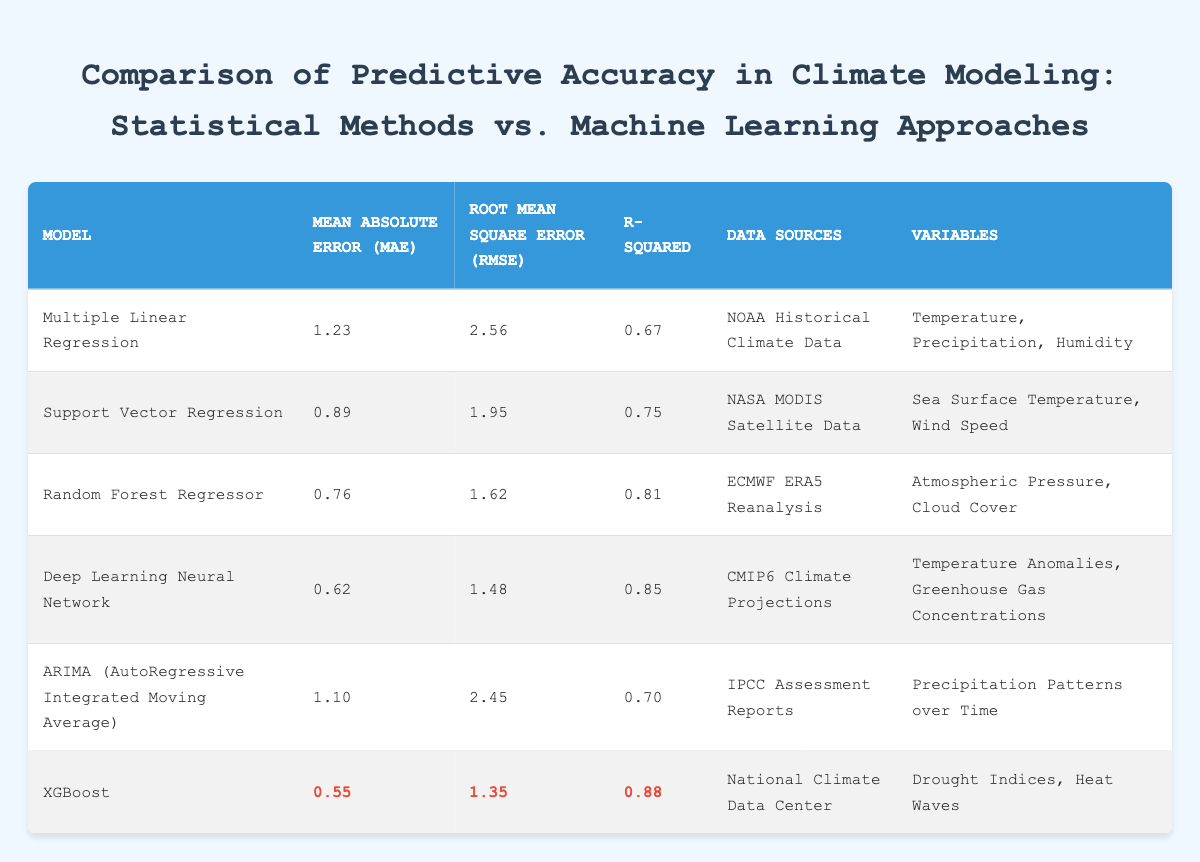What is the Mean Absolute Error (MAE) for the Random Forest Regressor? The table shows that the Mean Absolute Error (MAE) for the Random Forest Regressor is listed directly. By locating the corresponding row for Random Forest Regressor, we find the MAE value which is 0.76.
Answer: 0.76 Which model has the highest R-squared value? To determine the model with the highest R-squared value, we must compare the R-squared entries for each model listed in the table. The values are 0.67, 0.75, 0.81, 0.85, 0.70, and 0.88. The highest of these values is 0.88, which corresponds to the XGBoost model.
Answer: XGBoost What is the difference in Mean Absolute Error (MAE) between the Deep Learning Neural Network and the Multiple Linear Regression model? First, we identify the MAE values for both the Deep Learning Neural Network (0.62) and the Multiple Linear Regression (1.23). We then calculate the difference: 1.23 - 0.62 = 0.61.
Answer: 0.61 Is the Mean Absolute Error (MAE) for Support Vector Regression less than that of ARIMA? The MAE for Support Vector Regression is 0.89, and the MAE for ARIMA is 1.10. Comparing these values: 0.89 < 1.10 is true, thus supporting the statement.
Answer: Yes What is the average R-squared value of all the models listed in the table? We must find the R-squared values for all models: 0.67, 0.75, 0.81, 0.85, 0.70, and 0.88. Adding these values gives us 0.67 + 0.75 + 0.81 + 0.85 + 0.70 + 0.88 = 4.56. Since there are 6 models, we divide the total by 6: 4.56/6 = 0.76.
Answer: 0.76 Which model, based on the table, has the lowest Root Mean Square Error (RMSE)? The RMSE values for the models are: 2.56, 1.95, 1.62, 1.48, 2.45, and 1.35. To find the model with the lowest RMSE, we compare these values. The lowest is 1.35, which corresponds to the XGBoost model.
Answer: XGBoost How does the Mean Absolute Error (MAE) of XGBoost compare with that of the Deep Learning Neural Network? The table indicates that XGBoost has an MAE of 0.55 and the Deep Learning Neural Network has an MAE of 0.62. To compare: 0.55 < 0.62 indicates that XGBoost has a lower MAE than the Deep Learning Neural Network.
Answer: XGBoost has a lower MAE What is the total number of models that reported data from the NASA MODIS Satellite Data? Checking the table, we look for data sources that mention "NASA MODIS Satellite Data". Only the Support Vector Regression model lists this source, therefore the total number is 1.
Answer: 1 If you combine the R-squared values of Random Forest Regressor and XGBoost, what is the total? The R-squared for Random Forest Regressor is 0.81 and for XGBoost it is 0.88. Adding these together results in 0.81 + 0.88 = 1.69.
Answer: 1.69 Which statistical model had a higher Mean Absolute Error (MAE), Deep Learning Neural Network or Multiple Linear Regression? The MAE for Deep Learning Neural Network is 0.62, while for Multiple Linear Regression it is 1.23. Comparing the two values shows 1.23 > 0.62, meaning Multiple Linear Regression has a higher MAE.
Answer: Multiple Linear Regression 